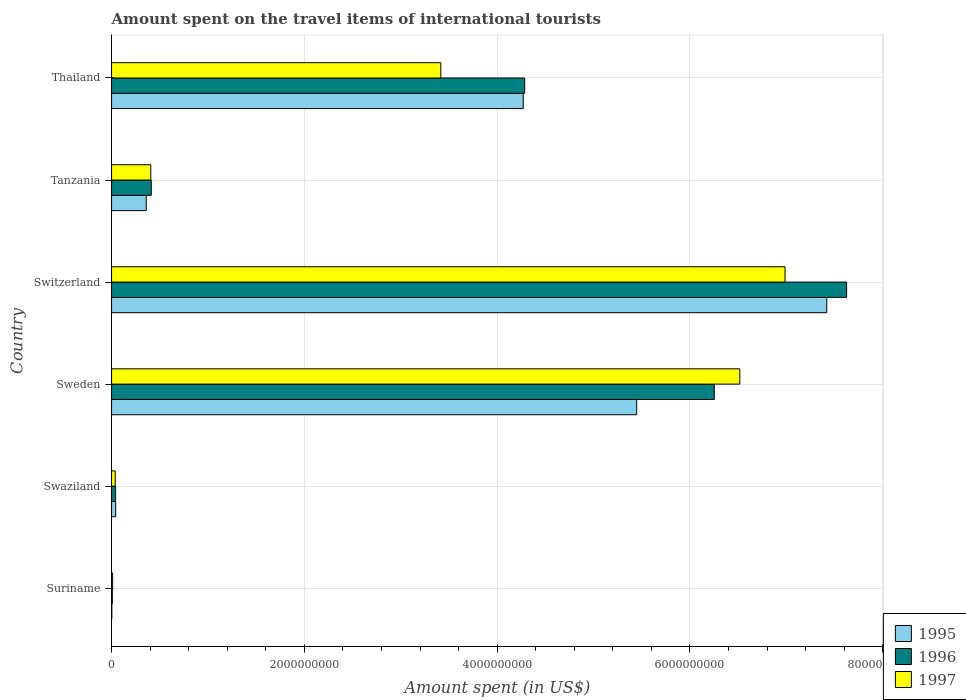How many different coloured bars are there?
Your answer should be compact. 3. In how many cases, is the number of bars for a given country not equal to the number of legend labels?
Ensure brevity in your answer.  0. What is the amount spent on the travel items of international tourists in 1997 in Switzerland?
Your response must be concise. 6.99e+09. Across all countries, what is the maximum amount spent on the travel items of international tourists in 1997?
Your answer should be very brief. 6.99e+09. Across all countries, what is the minimum amount spent on the travel items of international tourists in 1997?
Your answer should be compact. 1.10e+07. In which country was the amount spent on the travel items of international tourists in 1996 maximum?
Offer a very short reply. Switzerland. In which country was the amount spent on the travel items of international tourists in 1995 minimum?
Give a very brief answer. Suriname. What is the total amount spent on the travel items of international tourists in 1996 in the graph?
Offer a terse response. 1.86e+1. What is the difference between the amount spent on the travel items of international tourists in 1995 in Suriname and that in Thailand?
Ensure brevity in your answer.  -4.27e+09. What is the difference between the amount spent on the travel items of international tourists in 1996 in Thailand and the amount spent on the travel items of international tourists in 1995 in Suriname?
Offer a very short reply. 4.28e+09. What is the average amount spent on the travel items of international tourists in 1997 per country?
Ensure brevity in your answer.  2.90e+09. What is the difference between the amount spent on the travel items of international tourists in 1997 and amount spent on the travel items of international tourists in 1996 in Tanzania?
Provide a succinct answer. -5.00e+06. What is the ratio of the amount spent on the travel items of international tourists in 1996 in Tanzania to that in Thailand?
Provide a succinct answer. 0.1. Is the amount spent on the travel items of international tourists in 1997 in Sweden less than that in Switzerland?
Offer a very short reply. Yes. What is the difference between the highest and the second highest amount spent on the travel items of international tourists in 1996?
Make the answer very short. 1.37e+09. What is the difference between the highest and the lowest amount spent on the travel items of international tourists in 1996?
Your response must be concise. 7.62e+09. Is the sum of the amount spent on the travel items of international tourists in 1995 in Swaziland and Thailand greater than the maximum amount spent on the travel items of international tourists in 1997 across all countries?
Give a very brief answer. No. What does the 2nd bar from the top in Swaziland represents?
Your response must be concise. 1996. How many bars are there?
Give a very brief answer. 18. Where does the legend appear in the graph?
Give a very brief answer. Bottom right. How are the legend labels stacked?
Your response must be concise. Vertical. What is the title of the graph?
Provide a succinct answer. Amount spent on the travel items of international tourists. Does "1968" appear as one of the legend labels in the graph?
Give a very brief answer. No. What is the label or title of the X-axis?
Keep it short and to the point. Amount spent (in US$). What is the Amount spent (in US$) in 1995 in Suriname?
Offer a very short reply. 3.00e+06. What is the Amount spent (in US$) in 1996 in Suriname?
Your answer should be very brief. 8.00e+06. What is the Amount spent (in US$) of 1997 in Suriname?
Your answer should be compact. 1.10e+07. What is the Amount spent (in US$) in 1995 in Swaziland?
Your response must be concise. 4.30e+07. What is the Amount spent (in US$) in 1996 in Swaziland?
Offer a very short reply. 4.20e+07. What is the Amount spent (in US$) in 1997 in Swaziland?
Offer a very short reply. 3.80e+07. What is the Amount spent (in US$) in 1995 in Sweden?
Your answer should be very brief. 5.45e+09. What is the Amount spent (in US$) in 1996 in Sweden?
Offer a terse response. 6.25e+09. What is the Amount spent (in US$) in 1997 in Sweden?
Your response must be concise. 6.52e+09. What is the Amount spent (in US$) in 1995 in Switzerland?
Your answer should be compact. 7.42e+09. What is the Amount spent (in US$) in 1996 in Switzerland?
Your answer should be compact. 7.63e+09. What is the Amount spent (in US$) in 1997 in Switzerland?
Provide a short and direct response. 6.99e+09. What is the Amount spent (in US$) in 1995 in Tanzania?
Keep it short and to the point. 3.60e+08. What is the Amount spent (in US$) of 1996 in Tanzania?
Give a very brief answer. 4.12e+08. What is the Amount spent (in US$) in 1997 in Tanzania?
Give a very brief answer. 4.07e+08. What is the Amount spent (in US$) of 1995 in Thailand?
Make the answer very short. 4.27e+09. What is the Amount spent (in US$) in 1996 in Thailand?
Your response must be concise. 4.29e+09. What is the Amount spent (in US$) of 1997 in Thailand?
Your answer should be compact. 3.42e+09. Across all countries, what is the maximum Amount spent (in US$) in 1995?
Keep it short and to the point. 7.42e+09. Across all countries, what is the maximum Amount spent (in US$) of 1996?
Provide a succinct answer. 7.63e+09. Across all countries, what is the maximum Amount spent (in US$) in 1997?
Provide a succinct answer. 6.99e+09. Across all countries, what is the minimum Amount spent (in US$) of 1995?
Provide a succinct answer. 3.00e+06. Across all countries, what is the minimum Amount spent (in US$) in 1996?
Your answer should be very brief. 8.00e+06. Across all countries, what is the minimum Amount spent (in US$) of 1997?
Provide a short and direct response. 1.10e+07. What is the total Amount spent (in US$) in 1995 in the graph?
Your response must be concise. 1.75e+1. What is the total Amount spent (in US$) in 1996 in the graph?
Offer a very short reply. 1.86e+1. What is the total Amount spent (in US$) of 1997 in the graph?
Your answer should be compact. 1.74e+1. What is the difference between the Amount spent (in US$) in 1995 in Suriname and that in Swaziland?
Make the answer very short. -4.00e+07. What is the difference between the Amount spent (in US$) of 1996 in Suriname and that in Swaziland?
Give a very brief answer. -3.40e+07. What is the difference between the Amount spent (in US$) in 1997 in Suriname and that in Swaziland?
Provide a short and direct response. -2.70e+07. What is the difference between the Amount spent (in US$) in 1995 in Suriname and that in Sweden?
Make the answer very short. -5.44e+09. What is the difference between the Amount spent (in US$) in 1996 in Suriname and that in Sweden?
Your answer should be compact. -6.24e+09. What is the difference between the Amount spent (in US$) of 1997 in Suriname and that in Sweden?
Give a very brief answer. -6.51e+09. What is the difference between the Amount spent (in US$) of 1995 in Suriname and that in Switzerland?
Ensure brevity in your answer.  -7.42e+09. What is the difference between the Amount spent (in US$) in 1996 in Suriname and that in Switzerland?
Offer a very short reply. -7.62e+09. What is the difference between the Amount spent (in US$) of 1997 in Suriname and that in Switzerland?
Provide a succinct answer. -6.98e+09. What is the difference between the Amount spent (in US$) in 1995 in Suriname and that in Tanzania?
Ensure brevity in your answer.  -3.57e+08. What is the difference between the Amount spent (in US$) in 1996 in Suriname and that in Tanzania?
Your response must be concise. -4.04e+08. What is the difference between the Amount spent (in US$) of 1997 in Suriname and that in Tanzania?
Your answer should be compact. -3.96e+08. What is the difference between the Amount spent (in US$) of 1995 in Suriname and that in Thailand?
Your answer should be compact. -4.27e+09. What is the difference between the Amount spent (in US$) in 1996 in Suriname and that in Thailand?
Give a very brief answer. -4.28e+09. What is the difference between the Amount spent (in US$) of 1997 in Suriname and that in Thailand?
Offer a very short reply. -3.40e+09. What is the difference between the Amount spent (in US$) of 1995 in Swaziland and that in Sweden?
Ensure brevity in your answer.  -5.40e+09. What is the difference between the Amount spent (in US$) of 1996 in Swaziland and that in Sweden?
Keep it short and to the point. -6.21e+09. What is the difference between the Amount spent (in US$) of 1997 in Swaziland and that in Sweden?
Your answer should be compact. -6.48e+09. What is the difference between the Amount spent (in US$) in 1995 in Swaziland and that in Switzerland?
Provide a succinct answer. -7.38e+09. What is the difference between the Amount spent (in US$) in 1996 in Swaziland and that in Switzerland?
Your answer should be very brief. -7.58e+09. What is the difference between the Amount spent (in US$) in 1997 in Swaziland and that in Switzerland?
Ensure brevity in your answer.  -6.95e+09. What is the difference between the Amount spent (in US$) of 1995 in Swaziland and that in Tanzania?
Your answer should be compact. -3.17e+08. What is the difference between the Amount spent (in US$) of 1996 in Swaziland and that in Tanzania?
Your answer should be very brief. -3.70e+08. What is the difference between the Amount spent (in US$) in 1997 in Swaziland and that in Tanzania?
Your answer should be very brief. -3.69e+08. What is the difference between the Amount spent (in US$) of 1995 in Swaziland and that in Thailand?
Your answer should be very brief. -4.23e+09. What is the difference between the Amount spent (in US$) of 1996 in Swaziland and that in Thailand?
Make the answer very short. -4.24e+09. What is the difference between the Amount spent (in US$) in 1997 in Swaziland and that in Thailand?
Give a very brief answer. -3.38e+09. What is the difference between the Amount spent (in US$) in 1995 in Sweden and that in Switzerland?
Ensure brevity in your answer.  -1.97e+09. What is the difference between the Amount spent (in US$) of 1996 in Sweden and that in Switzerland?
Your response must be concise. -1.37e+09. What is the difference between the Amount spent (in US$) in 1997 in Sweden and that in Switzerland?
Make the answer very short. -4.69e+08. What is the difference between the Amount spent (in US$) in 1995 in Sweden and that in Tanzania?
Your answer should be very brief. 5.09e+09. What is the difference between the Amount spent (in US$) of 1996 in Sweden and that in Tanzania?
Make the answer very short. 5.84e+09. What is the difference between the Amount spent (in US$) of 1997 in Sweden and that in Tanzania?
Provide a short and direct response. 6.11e+09. What is the difference between the Amount spent (in US$) in 1995 in Sweden and that in Thailand?
Your response must be concise. 1.18e+09. What is the difference between the Amount spent (in US$) in 1996 in Sweden and that in Thailand?
Your answer should be very brief. 1.97e+09. What is the difference between the Amount spent (in US$) of 1997 in Sweden and that in Thailand?
Give a very brief answer. 3.10e+09. What is the difference between the Amount spent (in US$) of 1995 in Switzerland and that in Tanzania?
Keep it short and to the point. 7.06e+09. What is the difference between the Amount spent (in US$) of 1996 in Switzerland and that in Tanzania?
Your answer should be compact. 7.21e+09. What is the difference between the Amount spent (in US$) of 1997 in Switzerland and that in Tanzania?
Provide a succinct answer. 6.58e+09. What is the difference between the Amount spent (in US$) of 1995 in Switzerland and that in Thailand?
Your answer should be compact. 3.15e+09. What is the difference between the Amount spent (in US$) in 1996 in Switzerland and that in Thailand?
Keep it short and to the point. 3.34e+09. What is the difference between the Amount spent (in US$) in 1997 in Switzerland and that in Thailand?
Provide a succinct answer. 3.57e+09. What is the difference between the Amount spent (in US$) in 1995 in Tanzania and that in Thailand?
Give a very brief answer. -3.91e+09. What is the difference between the Amount spent (in US$) in 1996 in Tanzania and that in Thailand?
Offer a very short reply. -3.87e+09. What is the difference between the Amount spent (in US$) in 1997 in Tanzania and that in Thailand?
Give a very brief answer. -3.01e+09. What is the difference between the Amount spent (in US$) in 1995 in Suriname and the Amount spent (in US$) in 1996 in Swaziland?
Provide a short and direct response. -3.90e+07. What is the difference between the Amount spent (in US$) in 1995 in Suriname and the Amount spent (in US$) in 1997 in Swaziland?
Keep it short and to the point. -3.50e+07. What is the difference between the Amount spent (in US$) of 1996 in Suriname and the Amount spent (in US$) of 1997 in Swaziland?
Your answer should be compact. -3.00e+07. What is the difference between the Amount spent (in US$) of 1995 in Suriname and the Amount spent (in US$) of 1996 in Sweden?
Your answer should be very brief. -6.25e+09. What is the difference between the Amount spent (in US$) in 1995 in Suriname and the Amount spent (in US$) in 1997 in Sweden?
Your answer should be very brief. -6.52e+09. What is the difference between the Amount spent (in US$) in 1996 in Suriname and the Amount spent (in US$) in 1997 in Sweden?
Your answer should be very brief. -6.51e+09. What is the difference between the Amount spent (in US$) in 1995 in Suriname and the Amount spent (in US$) in 1996 in Switzerland?
Ensure brevity in your answer.  -7.62e+09. What is the difference between the Amount spent (in US$) of 1995 in Suriname and the Amount spent (in US$) of 1997 in Switzerland?
Give a very brief answer. -6.98e+09. What is the difference between the Amount spent (in US$) in 1996 in Suriname and the Amount spent (in US$) in 1997 in Switzerland?
Provide a succinct answer. -6.98e+09. What is the difference between the Amount spent (in US$) of 1995 in Suriname and the Amount spent (in US$) of 1996 in Tanzania?
Offer a very short reply. -4.09e+08. What is the difference between the Amount spent (in US$) in 1995 in Suriname and the Amount spent (in US$) in 1997 in Tanzania?
Keep it short and to the point. -4.04e+08. What is the difference between the Amount spent (in US$) of 1996 in Suriname and the Amount spent (in US$) of 1997 in Tanzania?
Offer a very short reply. -3.99e+08. What is the difference between the Amount spent (in US$) in 1995 in Suriname and the Amount spent (in US$) in 1996 in Thailand?
Offer a very short reply. -4.28e+09. What is the difference between the Amount spent (in US$) in 1995 in Suriname and the Amount spent (in US$) in 1997 in Thailand?
Your response must be concise. -3.41e+09. What is the difference between the Amount spent (in US$) in 1996 in Suriname and the Amount spent (in US$) in 1997 in Thailand?
Make the answer very short. -3.41e+09. What is the difference between the Amount spent (in US$) of 1995 in Swaziland and the Amount spent (in US$) of 1996 in Sweden?
Your answer should be compact. -6.21e+09. What is the difference between the Amount spent (in US$) of 1995 in Swaziland and the Amount spent (in US$) of 1997 in Sweden?
Make the answer very short. -6.48e+09. What is the difference between the Amount spent (in US$) of 1996 in Swaziland and the Amount spent (in US$) of 1997 in Sweden?
Ensure brevity in your answer.  -6.48e+09. What is the difference between the Amount spent (in US$) of 1995 in Swaziland and the Amount spent (in US$) of 1996 in Switzerland?
Ensure brevity in your answer.  -7.58e+09. What is the difference between the Amount spent (in US$) in 1995 in Swaziland and the Amount spent (in US$) in 1997 in Switzerland?
Offer a terse response. -6.94e+09. What is the difference between the Amount spent (in US$) of 1996 in Swaziland and the Amount spent (in US$) of 1997 in Switzerland?
Provide a short and direct response. -6.94e+09. What is the difference between the Amount spent (in US$) of 1995 in Swaziland and the Amount spent (in US$) of 1996 in Tanzania?
Make the answer very short. -3.69e+08. What is the difference between the Amount spent (in US$) in 1995 in Swaziland and the Amount spent (in US$) in 1997 in Tanzania?
Make the answer very short. -3.64e+08. What is the difference between the Amount spent (in US$) in 1996 in Swaziland and the Amount spent (in US$) in 1997 in Tanzania?
Offer a terse response. -3.65e+08. What is the difference between the Amount spent (in US$) in 1995 in Swaziland and the Amount spent (in US$) in 1996 in Thailand?
Your response must be concise. -4.24e+09. What is the difference between the Amount spent (in US$) of 1995 in Swaziland and the Amount spent (in US$) of 1997 in Thailand?
Your answer should be very brief. -3.37e+09. What is the difference between the Amount spent (in US$) of 1996 in Swaziland and the Amount spent (in US$) of 1997 in Thailand?
Offer a terse response. -3.37e+09. What is the difference between the Amount spent (in US$) in 1995 in Sweden and the Amount spent (in US$) in 1996 in Switzerland?
Your answer should be compact. -2.18e+09. What is the difference between the Amount spent (in US$) in 1995 in Sweden and the Amount spent (in US$) in 1997 in Switzerland?
Keep it short and to the point. -1.54e+09. What is the difference between the Amount spent (in US$) in 1996 in Sweden and the Amount spent (in US$) in 1997 in Switzerland?
Make the answer very short. -7.34e+08. What is the difference between the Amount spent (in US$) of 1995 in Sweden and the Amount spent (in US$) of 1996 in Tanzania?
Offer a terse response. 5.04e+09. What is the difference between the Amount spent (in US$) in 1995 in Sweden and the Amount spent (in US$) in 1997 in Tanzania?
Provide a succinct answer. 5.04e+09. What is the difference between the Amount spent (in US$) in 1996 in Sweden and the Amount spent (in US$) in 1997 in Tanzania?
Your answer should be compact. 5.85e+09. What is the difference between the Amount spent (in US$) in 1995 in Sweden and the Amount spent (in US$) in 1996 in Thailand?
Provide a succinct answer. 1.16e+09. What is the difference between the Amount spent (in US$) of 1995 in Sweden and the Amount spent (in US$) of 1997 in Thailand?
Offer a very short reply. 2.03e+09. What is the difference between the Amount spent (in US$) of 1996 in Sweden and the Amount spent (in US$) of 1997 in Thailand?
Provide a succinct answer. 2.84e+09. What is the difference between the Amount spent (in US$) in 1995 in Switzerland and the Amount spent (in US$) in 1996 in Tanzania?
Ensure brevity in your answer.  7.01e+09. What is the difference between the Amount spent (in US$) in 1995 in Switzerland and the Amount spent (in US$) in 1997 in Tanzania?
Your answer should be very brief. 7.01e+09. What is the difference between the Amount spent (in US$) in 1996 in Switzerland and the Amount spent (in US$) in 1997 in Tanzania?
Ensure brevity in your answer.  7.22e+09. What is the difference between the Amount spent (in US$) of 1995 in Switzerland and the Amount spent (in US$) of 1996 in Thailand?
Make the answer very short. 3.13e+09. What is the difference between the Amount spent (in US$) of 1995 in Switzerland and the Amount spent (in US$) of 1997 in Thailand?
Your answer should be compact. 4.00e+09. What is the difference between the Amount spent (in US$) in 1996 in Switzerland and the Amount spent (in US$) in 1997 in Thailand?
Provide a short and direct response. 4.21e+09. What is the difference between the Amount spent (in US$) in 1995 in Tanzania and the Amount spent (in US$) in 1996 in Thailand?
Keep it short and to the point. -3.93e+09. What is the difference between the Amount spent (in US$) in 1995 in Tanzania and the Amount spent (in US$) in 1997 in Thailand?
Offer a terse response. -3.06e+09. What is the difference between the Amount spent (in US$) of 1996 in Tanzania and the Amount spent (in US$) of 1997 in Thailand?
Make the answer very short. -3.00e+09. What is the average Amount spent (in US$) of 1995 per country?
Offer a terse response. 2.92e+09. What is the average Amount spent (in US$) in 1996 per country?
Offer a terse response. 3.10e+09. What is the average Amount spent (in US$) in 1997 per country?
Your response must be concise. 2.90e+09. What is the difference between the Amount spent (in US$) in 1995 and Amount spent (in US$) in 1996 in Suriname?
Offer a terse response. -5.00e+06. What is the difference between the Amount spent (in US$) of 1995 and Amount spent (in US$) of 1997 in Suriname?
Provide a succinct answer. -8.00e+06. What is the difference between the Amount spent (in US$) in 1995 and Amount spent (in US$) in 1996 in Swaziland?
Offer a terse response. 1.00e+06. What is the difference between the Amount spent (in US$) in 1995 and Amount spent (in US$) in 1996 in Sweden?
Your response must be concise. -8.05e+08. What is the difference between the Amount spent (in US$) of 1995 and Amount spent (in US$) of 1997 in Sweden?
Offer a very short reply. -1.07e+09. What is the difference between the Amount spent (in US$) in 1996 and Amount spent (in US$) in 1997 in Sweden?
Make the answer very short. -2.65e+08. What is the difference between the Amount spent (in US$) of 1995 and Amount spent (in US$) of 1996 in Switzerland?
Offer a terse response. -2.06e+08. What is the difference between the Amount spent (in US$) in 1995 and Amount spent (in US$) in 1997 in Switzerland?
Make the answer very short. 4.33e+08. What is the difference between the Amount spent (in US$) in 1996 and Amount spent (in US$) in 1997 in Switzerland?
Your answer should be compact. 6.39e+08. What is the difference between the Amount spent (in US$) of 1995 and Amount spent (in US$) of 1996 in Tanzania?
Offer a very short reply. -5.20e+07. What is the difference between the Amount spent (in US$) of 1995 and Amount spent (in US$) of 1997 in Tanzania?
Offer a very short reply. -4.70e+07. What is the difference between the Amount spent (in US$) of 1996 and Amount spent (in US$) of 1997 in Tanzania?
Your response must be concise. 5.00e+06. What is the difference between the Amount spent (in US$) of 1995 and Amount spent (in US$) of 1996 in Thailand?
Your response must be concise. -1.50e+07. What is the difference between the Amount spent (in US$) of 1995 and Amount spent (in US$) of 1997 in Thailand?
Ensure brevity in your answer.  8.55e+08. What is the difference between the Amount spent (in US$) in 1996 and Amount spent (in US$) in 1997 in Thailand?
Keep it short and to the point. 8.70e+08. What is the ratio of the Amount spent (in US$) of 1995 in Suriname to that in Swaziland?
Make the answer very short. 0.07. What is the ratio of the Amount spent (in US$) of 1996 in Suriname to that in Swaziland?
Offer a very short reply. 0.19. What is the ratio of the Amount spent (in US$) in 1997 in Suriname to that in Swaziland?
Your response must be concise. 0.29. What is the ratio of the Amount spent (in US$) of 1995 in Suriname to that in Sweden?
Give a very brief answer. 0. What is the ratio of the Amount spent (in US$) in 1996 in Suriname to that in Sweden?
Offer a terse response. 0. What is the ratio of the Amount spent (in US$) of 1997 in Suriname to that in Sweden?
Offer a terse response. 0. What is the ratio of the Amount spent (in US$) of 1997 in Suriname to that in Switzerland?
Offer a terse response. 0. What is the ratio of the Amount spent (in US$) in 1995 in Suriname to that in Tanzania?
Your response must be concise. 0.01. What is the ratio of the Amount spent (in US$) in 1996 in Suriname to that in Tanzania?
Your answer should be very brief. 0.02. What is the ratio of the Amount spent (in US$) of 1997 in Suriname to that in Tanzania?
Give a very brief answer. 0.03. What is the ratio of the Amount spent (in US$) of 1995 in Suriname to that in Thailand?
Make the answer very short. 0. What is the ratio of the Amount spent (in US$) in 1996 in Suriname to that in Thailand?
Make the answer very short. 0. What is the ratio of the Amount spent (in US$) of 1997 in Suriname to that in Thailand?
Keep it short and to the point. 0. What is the ratio of the Amount spent (in US$) in 1995 in Swaziland to that in Sweden?
Your answer should be compact. 0.01. What is the ratio of the Amount spent (in US$) of 1996 in Swaziland to that in Sweden?
Offer a terse response. 0.01. What is the ratio of the Amount spent (in US$) in 1997 in Swaziland to that in Sweden?
Your answer should be compact. 0.01. What is the ratio of the Amount spent (in US$) of 1995 in Swaziland to that in Switzerland?
Provide a short and direct response. 0.01. What is the ratio of the Amount spent (in US$) of 1996 in Swaziland to that in Switzerland?
Your answer should be compact. 0.01. What is the ratio of the Amount spent (in US$) in 1997 in Swaziland to that in Switzerland?
Give a very brief answer. 0.01. What is the ratio of the Amount spent (in US$) in 1995 in Swaziland to that in Tanzania?
Ensure brevity in your answer.  0.12. What is the ratio of the Amount spent (in US$) in 1996 in Swaziland to that in Tanzania?
Give a very brief answer. 0.1. What is the ratio of the Amount spent (in US$) in 1997 in Swaziland to that in Tanzania?
Offer a very short reply. 0.09. What is the ratio of the Amount spent (in US$) in 1995 in Swaziland to that in Thailand?
Offer a very short reply. 0.01. What is the ratio of the Amount spent (in US$) of 1996 in Swaziland to that in Thailand?
Make the answer very short. 0.01. What is the ratio of the Amount spent (in US$) in 1997 in Swaziland to that in Thailand?
Ensure brevity in your answer.  0.01. What is the ratio of the Amount spent (in US$) of 1995 in Sweden to that in Switzerland?
Offer a terse response. 0.73. What is the ratio of the Amount spent (in US$) in 1996 in Sweden to that in Switzerland?
Your answer should be very brief. 0.82. What is the ratio of the Amount spent (in US$) of 1997 in Sweden to that in Switzerland?
Give a very brief answer. 0.93. What is the ratio of the Amount spent (in US$) in 1995 in Sweden to that in Tanzania?
Ensure brevity in your answer.  15.13. What is the ratio of the Amount spent (in US$) in 1996 in Sweden to that in Tanzania?
Your answer should be very brief. 15.18. What is the ratio of the Amount spent (in US$) of 1997 in Sweden to that in Tanzania?
Your response must be concise. 16.01. What is the ratio of the Amount spent (in US$) in 1995 in Sweden to that in Thailand?
Ensure brevity in your answer.  1.28. What is the ratio of the Amount spent (in US$) of 1996 in Sweden to that in Thailand?
Provide a short and direct response. 1.46. What is the ratio of the Amount spent (in US$) of 1997 in Sweden to that in Thailand?
Provide a short and direct response. 1.91. What is the ratio of the Amount spent (in US$) of 1995 in Switzerland to that in Tanzania?
Offer a very short reply. 20.61. What is the ratio of the Amount spent (in US$) of 1996 in Switzerland to that in Tanzania?
Give a very brief answer. 18.51. What is the ratio of the Amount spent (in US$) in 1997 in Switzerland to that in Tanzania?
Provide a succinct answer. 17.17. What is the ratio of the Amount spent (in US$) in 1995 in Switzerland to that in Thailand?
Ensure brevity in your answer.  1.74. What is the ratio of the Amount spent (in US$) of 1996 in Switzerland to that in Thailand?
Ensure brevity in your answer.  1.78. What is the ratio of the Amount spent (in US$) in 1997 in Switzerland to that in Thailand?
Keep it short and to the point. 2.05. What is the ratio of the Amount spent (in US$) in 1995 in Tanzania to that in Thailand?
Ensure brevity in your answer.  0.08. What is the ratio of the Amount spent (in US$) in 1996 in Tanzania to that in Thailand?
Offer a very short reply. 0.1. What is the ratio of the Amount spent (in US$) of 1997 in Tanzania to that in Thailand?
Keep it short and to the point. 0.12. What is the difference between the highest and the second highest Amount spent (in US$) in 1995?
Make the answer very short. 1.97e+09. What is the difference between the highest and the second highest Amount spent (in US$) of 1996?
Your answer should be compact. 1.37e+09. What is the difference between the highest and the second highest Amount spent (in US$) of 1997?
Give a very brief answer. 4.69e+08. What is the difference between the highest and the lowest Amount spent (in US$) in 1995?
Keep it short and to the point. 7.42e+09. What is the difference between the highest and the lowest Amount spent (in US$) of 1996?
Your answer should be very brief. 7.62e+09. What is the difference between the highest and the lowest Amount spent (in US$) in 1997?
Keep it short and to the point. 6.98e+09. 